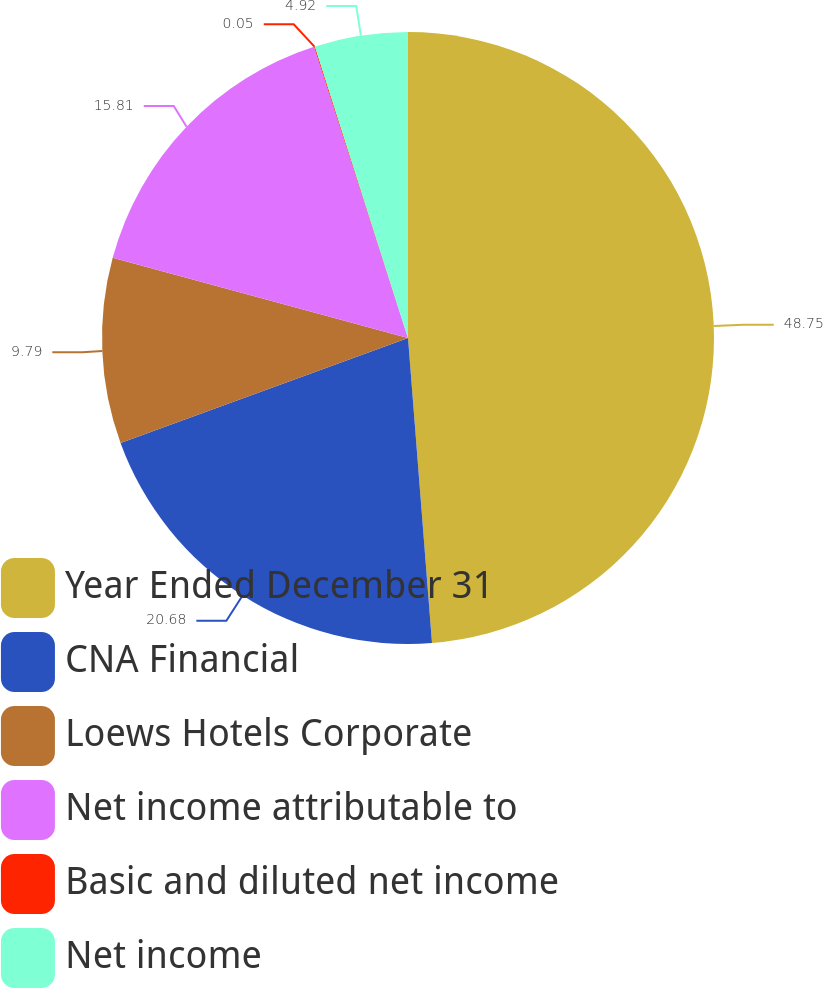Convert chart to OTSL. <chart><loc_0><loc_0><loc_500><loc_500><pie_chart><fcel>Year Ended December 31<fcel>CNA Financial<fcel>Loews Hotels Corporate<fcel>Net income attributable to<fcel>Basic and diluted net income<fcel>Net income<nl><fcel>48.75%<fcel>20.68%<fcel>9.79%<fcel>15.81%<fcel>0.05%<fcel>4.92%<nl></chart> 